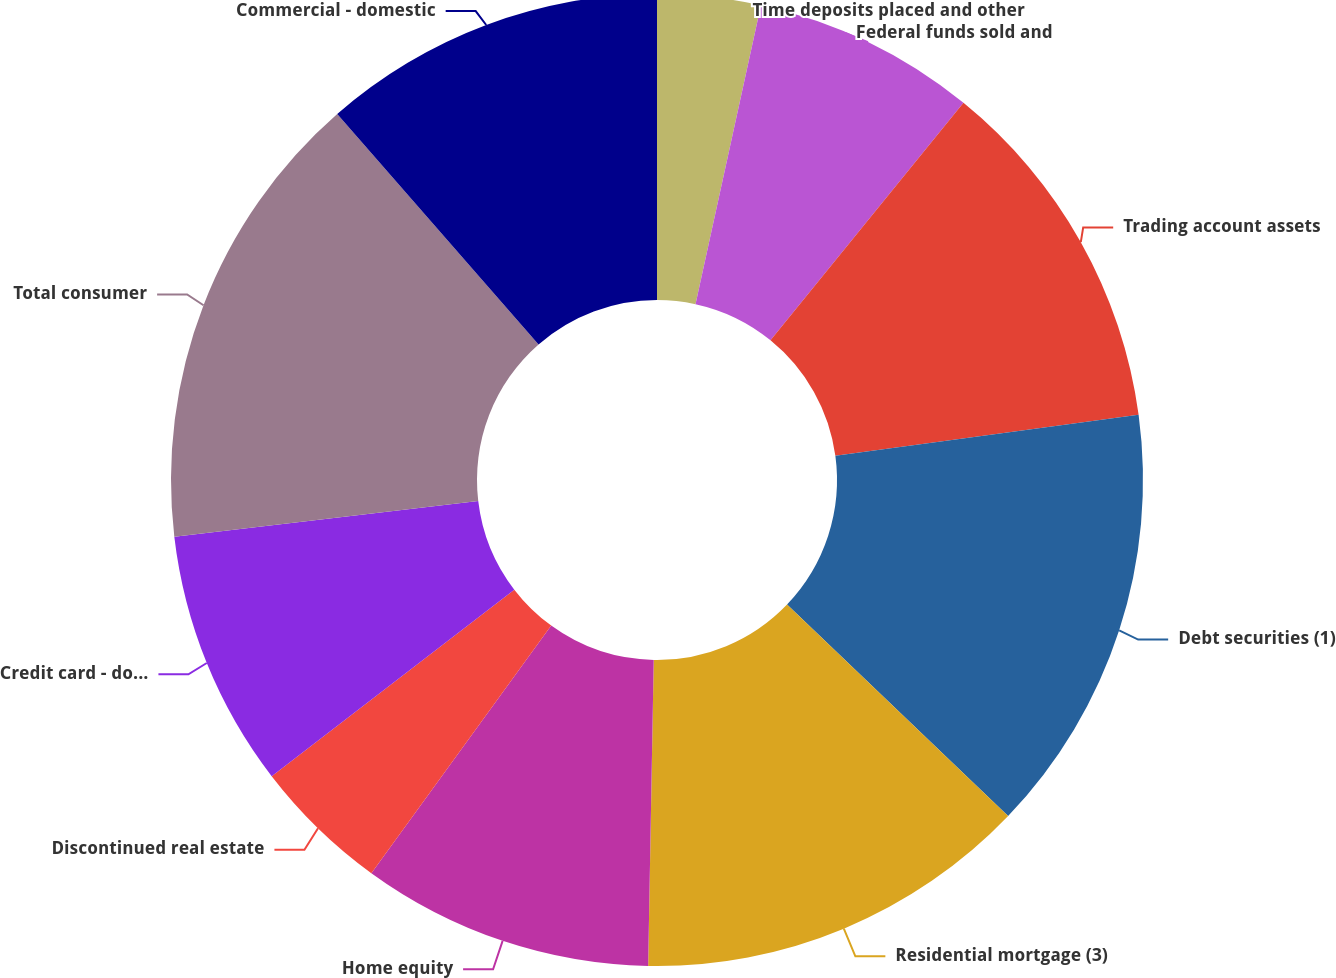<chart> <loc_0><loc_0><loc_500><loc_500><pie_chart><fcel>Time deposits placed and other<fcel>Federal funds sold and<fcel>Trading account assets<fcel>Debt securities (1)<fcel>Residential mortgage (3)<fcel>Home equity<fcel>Discontinued real estate<fcel>Credit card - domestic<fcel>Total consumer<fcel>Commercial - domestic<nl><fcel>3.43%<fcel>7.43%<fcel>12.0%<fcel>14.29%<fcel>13.14%<fcel>9.71%<fcel>4.57%<fcel>8.57%<fcel>15.43%<fcel>11.43%<nl></chart> 